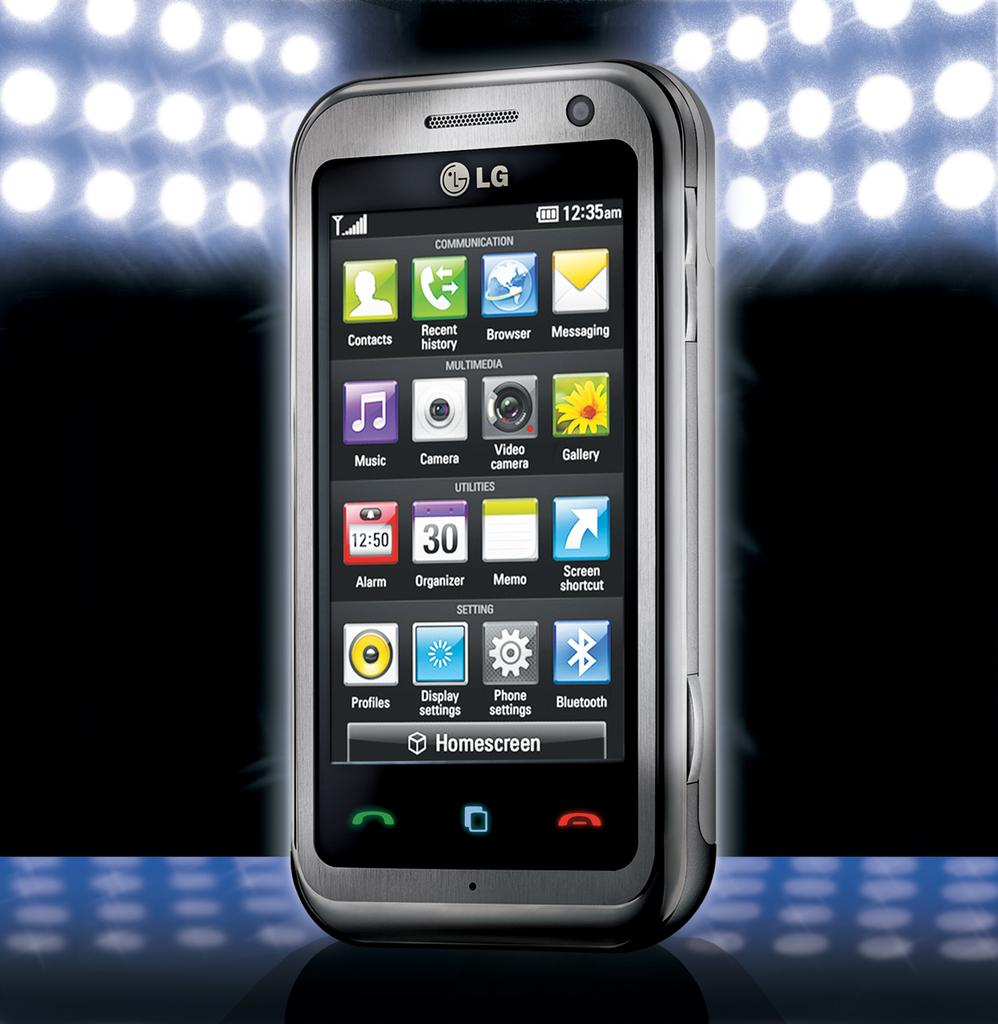Provide a one-sentence caption for the provided image. An LG phone with various icons displayed like Camera, Organizer, and Bluetooth. 